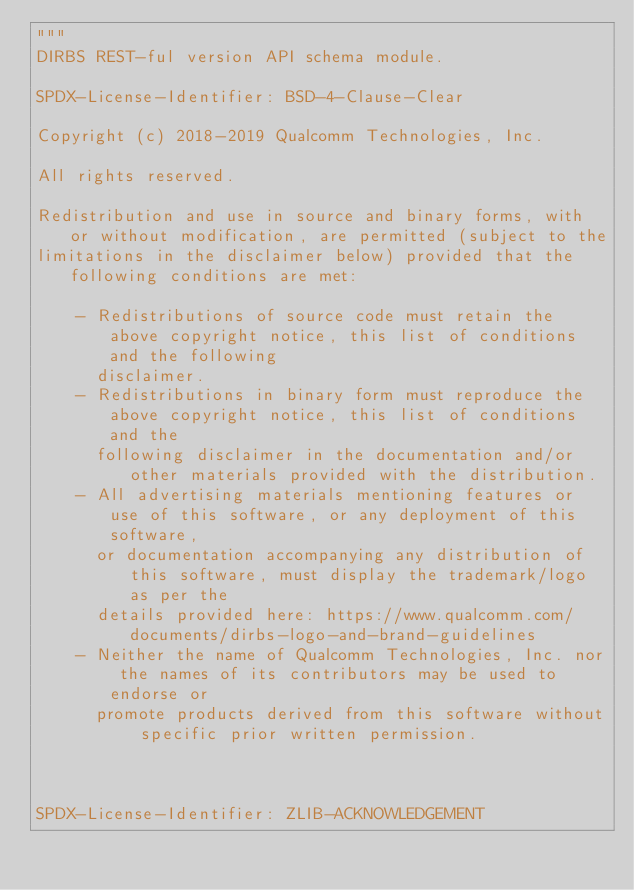<code> <loc_0><loc_0><loc_500><loc_500><_Python_>"""
DIRBS REST-ful version API schema module.

SPDX-License-Identifier: BSD-4-Clause-Clear

Copyright (c) 2018-2019 Qualcomm Technologies, Inc.

All rights reserved.

Redistribution and use in source and binary forms, with or without modification, are permitted (subject to the
limitations in the disclaimer below) provided that the following conditions are met:

    - Redistributions of source code must retain the above copyright notice, this list of conditions and the following
      disclaimer.
    - Redistributions in binary form must reproduce the above copyright notice, this list of conditions and the
      following disclaimer in the documentation and/or other materials provided with the distribution.
    - All advertising materials mentioning features or use of this software, or any deployment of this software,
      or documentation accompanying any distribution of this software, must display the trademark/logo as per the
      details provided here: https://www.qualcomm.com/documents/dirbs-logo-and-brand-guidelines
    - Neither the name of Qualcomm Technologies, Inc. nor the names of its contributors may be used to endorse or
      promote products derived from this software without specific prior written permission.



SPDX-License-Identifier: ZLIB-ACKNOWLEDGEMENT
</code> 